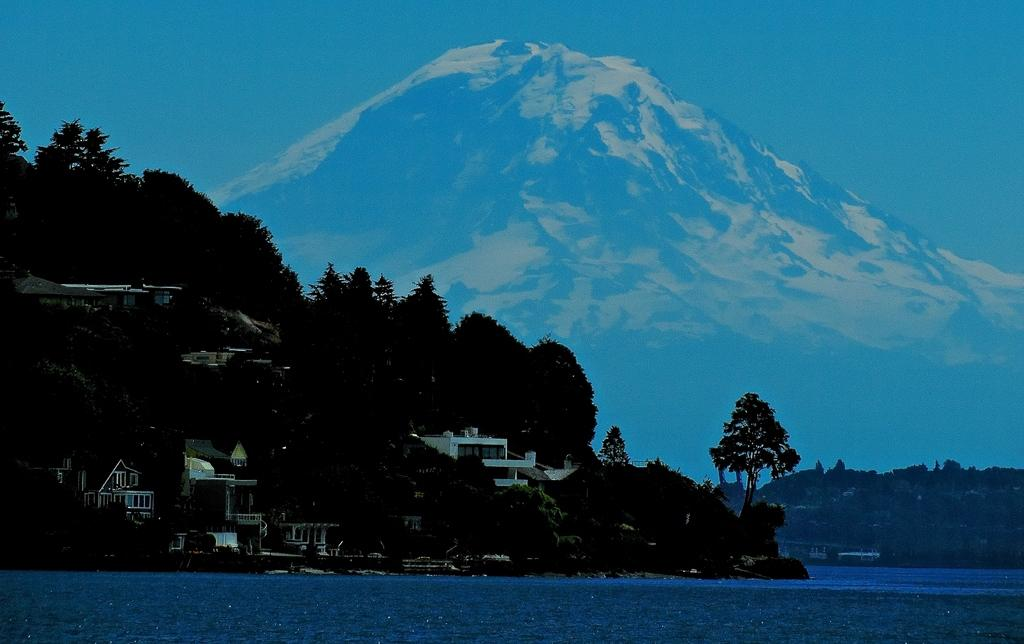What is located in the center of the image? There are buildings in the center of the image. What type of vegetation can be seen in the image? Trees are present in the image. What geographical feature is visible at the top of the image? There is a mountain visible at the top of the image. What is visible at the top of the image besides the mountain? The sky is visible at the top of the image. What is present at the bottom of the image? There is water present at the bottom of the image. How many cakes are being served at the picnic in the image? There is no picnic or cakes present in the image. What type of bird can be seen flying over the mountain in the image? There is no bird visible in the image; only buildings, trees, a mountain, the sky, and water are present. 